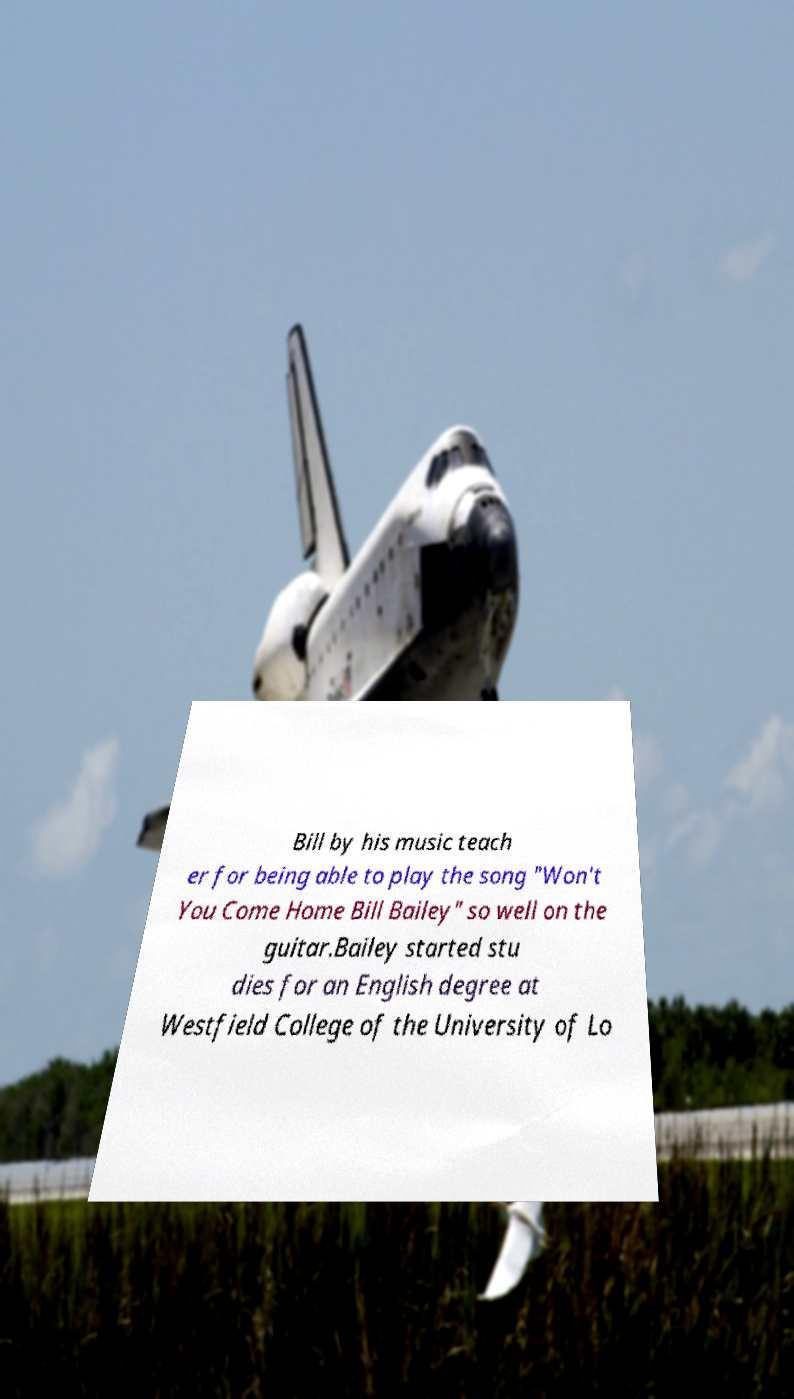Could you extract and type out the text from this image? Bill by his music teach er for being able to play the song "Won't You Come Home Bill Bailey" so well on the guitar.Bailey started stu dies for an English degree at Westfield College of the University of Lo 